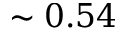<formula> <loc_0><loc_0><loc_500><loc_500>\sim 0 . 5 4</formula> 